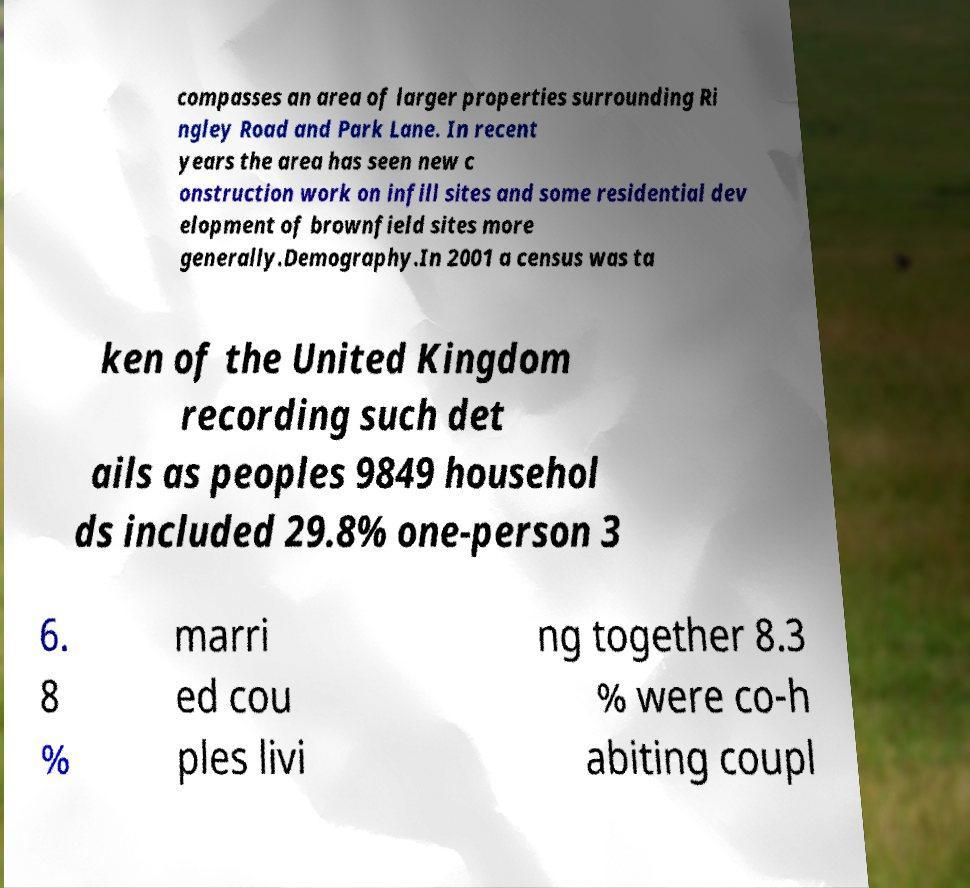For documentation purposes, I need the text within this image transcribed. Could you provide that? compasses an area of larger properties surrounding Ri ngley Road and Park Lane. In recent years the area has seen new c onstruction work on infill sites and some residential dev elopment of brownfield sites more generally.Demography.In 2001 a census was ta ken of the United Kingdom recording such det ails as peoples 9849 househol ds included 29.8% one-person 3 6. 8 % marri ed cou ples livi ng together 8.3 % were co-h abiting coupl 